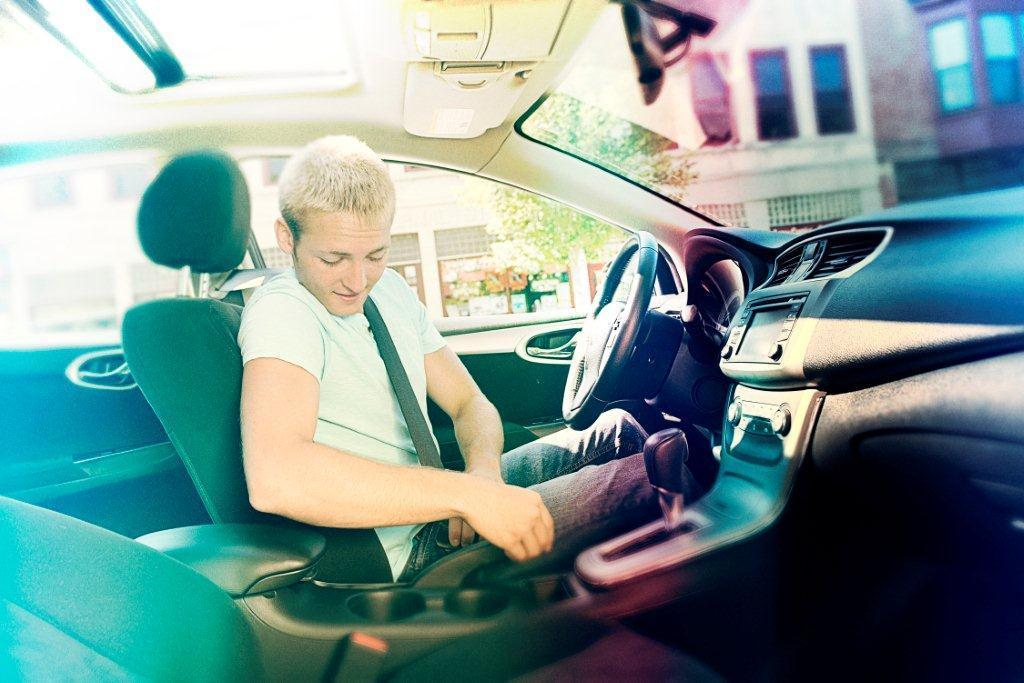What is inside the car in the image? There is a man inside the car in the image. What feature is present in the car for controlling its direction? The car has a steering wheel. What is provided for the driver to sit on while driving the car? The car has a seat. What type of structure can be seen in the background of the image? There is a building in the image. What type of plant is visible in the image? There is a tree in the image. Where is the nearest water source to the car in the image? There is no information about a water source in the image, so it cannot be determined. What type of animals can be seen at the zoo in the image? There is no zoo present in the image, so it cannot be determined. 